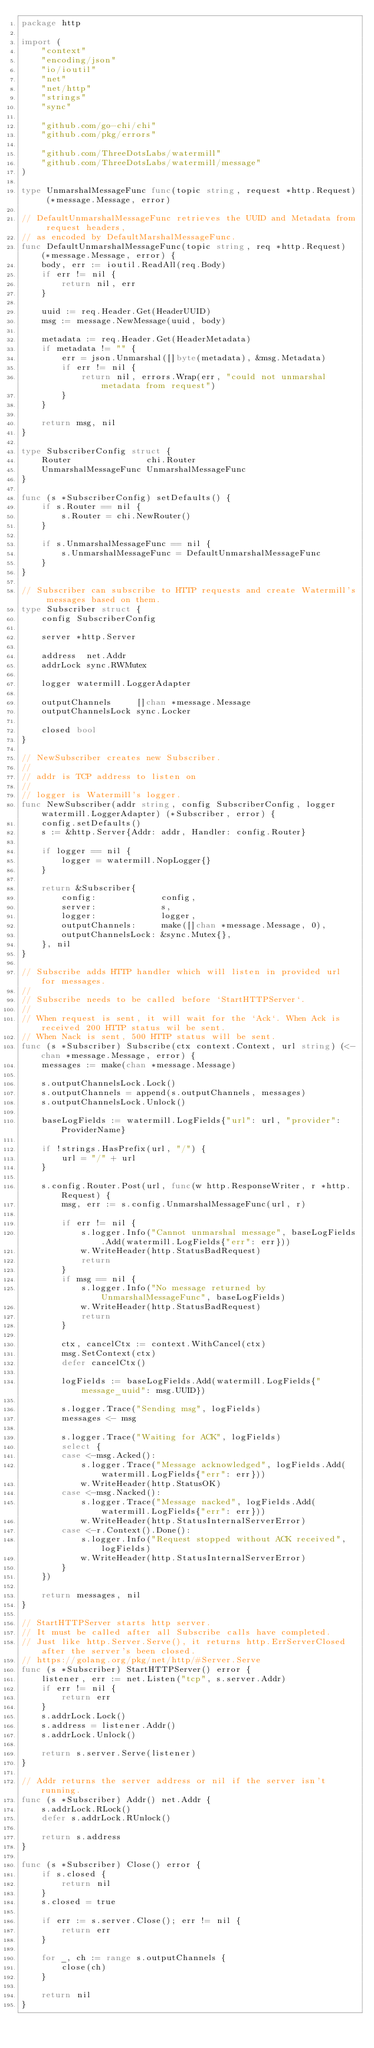<code> <loc_0><loc_0><loc_500><loc_500><_Go_>package http

import (
	"context"
	"encoding/json"
	"io/ioutil"
	"net"
	"net/http"
	"strings"
	"sync"

	"github.com/go-chi/chi"
	"github.com/pkg/errors"

	"github.com/ThreeDotsLabs/watermill"
	"github.com/ThreeDotsLabs/watermill/message"
)

type UnmarshalMessageFunc func(topic string, request *http.Request) (*message.Message, error)

// DefaultUnmarshalMessageFunc retrieves the UUID and Metadata from request headers,
// as encoded by DefaultMarshalMessageFunc.
func DefaultUnmarshalMessageFunc(topic string, req *http.Request) (*message.Message, error) {
	body, err := ioutil.ReadAll(req.Body)
	if err != nil {
		return nil, err
	}

	uuid := req.Header.Get(HeaderUUID)
	msg := message.NewMessage(uuid, body)

	metadata := req.Header.Get(HeaderMetadata)
	if metadata != "" {
		err = json.Unmarshal([]byte(metadata), &msg.Metadata)
		if err != nil {
			return nil, errors.Wrap(err, "could not unmarshal metadata from request")
		}
	}

	return msg, nil
}

type SubscriberConfig struct {
	Router               chi.Router
	UnmarshalMessageFunc UnmarshalMessageFunc
}

func (s *SubscriberConfig) setDefaults() {
	if s.Router == nil {
		s.Router = chi.NewRouter()
	}

	if s.UnmarshalMessageFunc == nil {
		s.UnmarshalMessageFunc = DefaultUnmarshalMessageFunc
	}
}

// Subscriber can subscribe to HTTP requests and create Watermill's messages based on them.
type Subscriber struct {
	config SubscriberConfig

	server *http.Server

	address  net.Addr
	addrLock sync.RWMutex

	logger watermill.LoggerAdapter

	outputChannels     []chan *message.Message
	outputChannelsLock sync.Locker

	closed bool
}

// NewSubscriber creates new Subscriber.
//
// addr is TCP address to listen on
//
// logger is Watermill's logger.
func NewSubscriber(addr string, config SubscriberConfig, logger watermill.LoggerAdapter) (*Subscriber, error) {
	config.setDefaults()
	s := &http.Server{Addr: addr, Handler: config.Router}

	if logger == nil {
		logger = watermill.NopLogger{}
	}

	return &Subscriber{
		config:             config,
		server:             s,
		logger:             logger,
		outputChannels:     make([]chan *message.Message, 0),
		outputChannelsLock: &sync.Mutex{},
	}, nil
}

// Subscribe adds HTTP handler which will listen in provided url for messages.
//
// Subscribe needs to be called before `StartHTTPServer`.
//
// When request is sent, it will wait for the `Ack`. When Ack is received 200 HTTP status wil be sent.
// When Nack is sent, 500 HTTP status will be sent.
func (s *Subscriber) Subscribe(ctx context.Context, url string) (<-chan *message.Message, error) {
	messages := make(chan *message.Message)

	s.outputChannelsLock.Lock()
	s.outputChannels = append(s.outputChannels, messages)
	s.outputChannelsLock.Unlock()

	baseLogFields := watermill.LogFields{"url": url, "provider": ProviderName}

	if !strings.HasPrefix(url, "/") {
		url = "/" + url
	}

	s.config.Router.Post(url, func(w http.ResponseWriter, r *http.Request) {
		msg, err := s.config.UnmarshalMessageFunc(url, r)

		if err != nil {
			s.logger.Info("Cannot unmarshal message", baseLogFields.Add(watermill.LogFields{"err": err}))
			w.WriteHeader(http.StatusBadRequest)
			return
		}
		if msg == nil {
			s.logger.Info("No message returned by UnmarshalMessageFunc", baseLogFields)
			w.WriteHeader(http.StatusBadRequest)
			return
		}

		ctx, cancelCtx := context.WithCancel(ctx)
		msg.SetContext(ctx)
		defer cancelCtx()

		logFields := baseLogFields.Add(watermill.LogFields{"message_uuid": msg.UUID})

		s.logger.Trace("Sending msg", logFields)
		messages <- msg

		s.logger.Trace("Waiting for ACK", logFields)
		select {
		case <-msg.Acked():
			s.logger.Trace("Message acknowledged", logFields.Add(watermill.LogFields{"err": err}))
			w.WriteHeader(http.StatusOK)
		case <-msg.Nacked():
			s.logger.Trace("Message nacked", logFields.Add(watermill.LogFields{"err": err}))
			w.WriteHeader(http.StatusInternalServerError)
		case <-r.Context().Done():
			s.logger.Info("Request stopped without ACK received", logFields)
			w.WriteHeader(http.StatusInternalServerError)
		}
	})

	return messages, nil
}

// StartHTTPServer starts http server.
// It must be called after all Subscribe calls have completed.
// Just like http.Server.Serve(), it returns http.ErrServerClosed after the server's been closed.
// https://golang.org/pkg/net/http/#Server.Serve
func (s *Subscriber) StartHTTPServer() error {
	listener, err := net.Listen("tcp", s.server.Addr)
	if err != nil {
		return err
	}
	s.addrLock.Lock()
	s.address = listener.Addr()
	s.addrLock.Unlock()

	return s.server.Serve(listener)
}

// Addr returns the server address or nil if the server isn't running.
func (s *Subscriber) Addr() net.Addr {
	s.addrLock.RLock()
	defer s.addrLock.RUnlock()

	return s.address
}

func (s *Subscriber) Close() error {
	if s.closed {
		return nil
	}
	s.closed = true

	if err := s.server.Close(); err != nil {
		return err
	}

	for _, ch := range s.outputChannels {
		close(ch)
	}

	return nil
}
</code> 